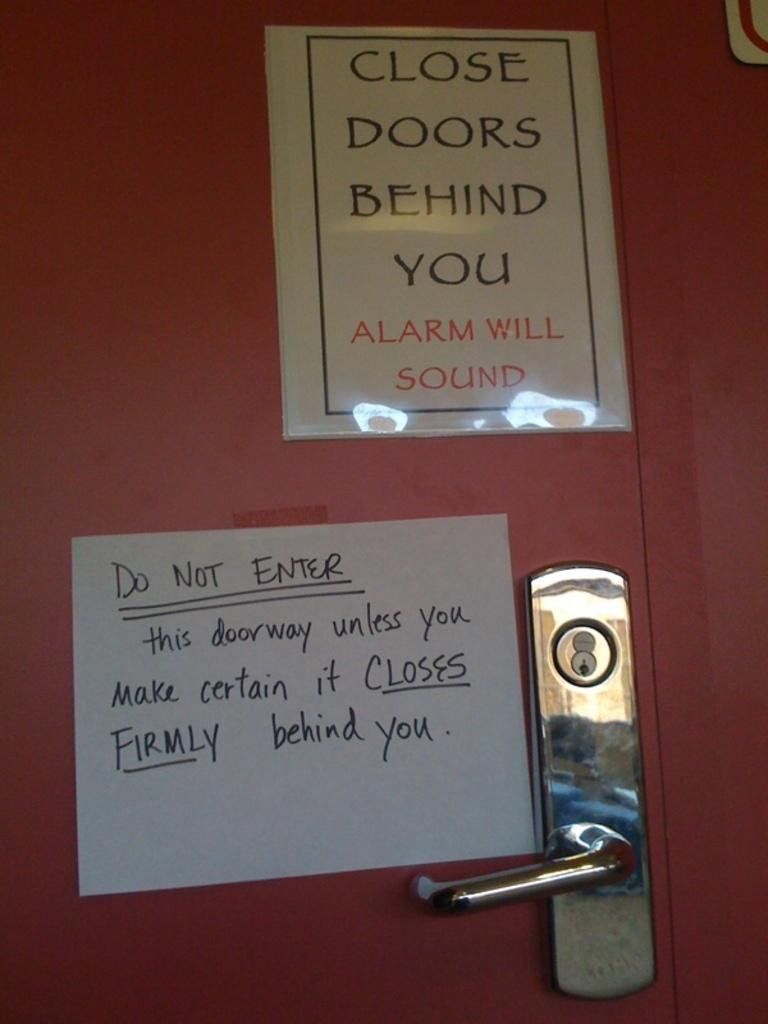<image>
Relay a brief, clear account of the picture shown. A door with a metallic handle with two signs that read close doors behind you and do not enter. 